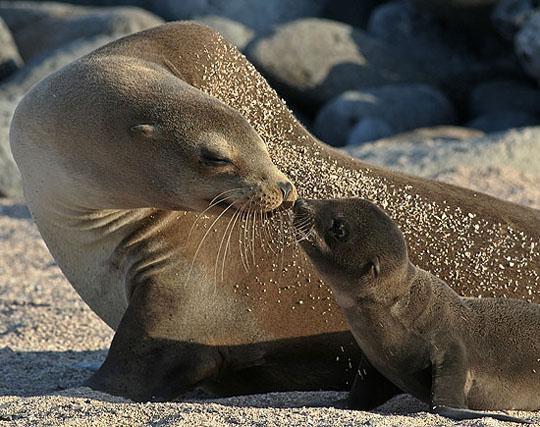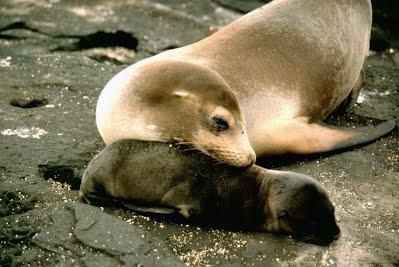The first image is the image on the left, the second image is the image on the right. For the images displayed, is the sentence "A juvenile sea lion can be seen near an adult sea lion." factually correct? Answer yes or no. Yes. The first image is the image on the left, the second image is the image on the right. For the images shown, is this caption "There are no more than four animals." true? Answer yes or no. Yes. 